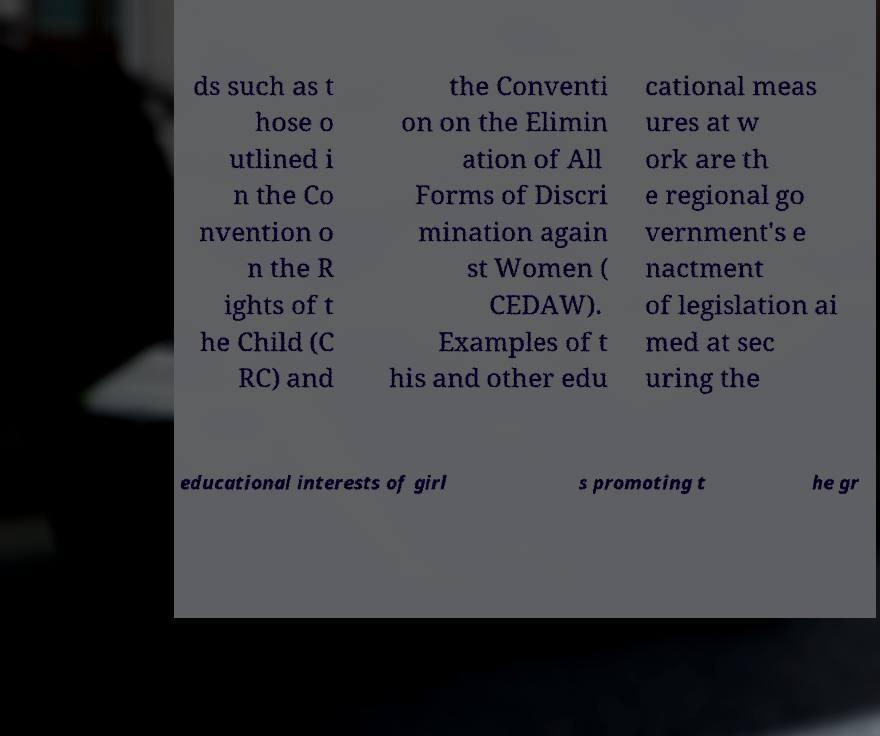For documentation purposes, I need the text within this image transcribed. Could you provide that? ds such as t hose o utlined i n the Co nvention o n the R ights of t he Child (C RC) and the Conventi on on the Elimin ation of All Forms of Discri mination again st Women ( CEDAW). Examples of t his and other edu cational meas ures at w ork are th e regional go vernment's e nactment of legislation ai med at sec uring the educational interests of girl s promoting t he gr 